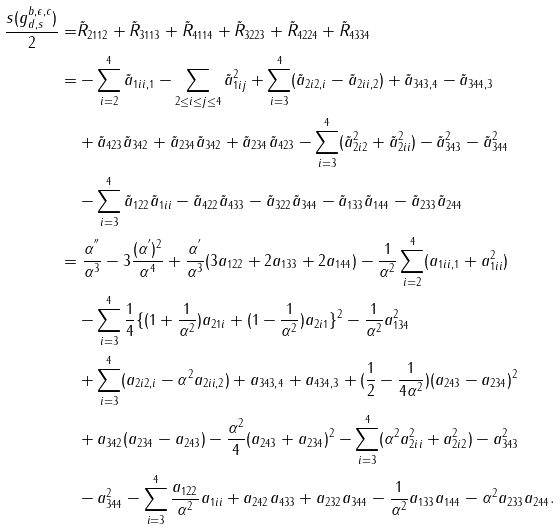<formula> <loc_0><loc_0><loc_500><loc_500>\frac { s ( g _ { d , s } ^ { b , \epsilon , c } ) } { 2 } = & \tilde { R } _ { 2 1 1 2 } + \tilde { R } _ { 3 1 1 3 } + \tilde { R } _ { 4 1 1 4 } + \tilde { R } _ { 3 2 2 3 } + \tilde { R } _ { 4 2 2 4 } + \tilde { R } _ { 4 3 3 4 } \\ = & - \sum _ { i = 2 } ^ { 4 } \tilde { a } _ { 1 i i , 1 } - \sum _ { 2 \leq i \leq j \leq 4 } \tilde { a } _ { 1 i j } ^ { 2 } + \sum _ { i = 3 } ^ { 4 } ( \tilde { a } _ { 2 i 2 , i } - \tilde { a } _ { 2 i i , 2 } ) + \tilde { a } _ { 3 4 3 , 4 } - \tilde { a } _ { 3 4 4 , 3 } \\ & + \tilde { a } _ { 4 2 3 } \tilde { a } _ { 3 4 2 } + \tilde { a } _ { 2 3 4 } \tilde { a } _ { 3 4 2 } + \tilde { a } _ { 2 3 4 } \tilde { a } _ { 4 2 3 } - \sum _ { i = 3 } ^ { 4 } ( \tilde { a } _ { 2 i 2 } ^ { 2 } + \tilde { a } _ { 2 i i } ^ { 2 } ) - \tilde { a } _ { 3 4 3 } ^ { 2 } - \tilde { a } _ { 3 4 4 } ^ { 2 } \\ & - \sum _ { i = 3 } ^ { 4 } \tilde { a } _ { 1 2 2 } \tilde { a } _ { 1 i i } - \tilde { a } _ { 4 2 2 } \tilde { a } _ { 4 3 3 } - \tilde { a } _ { 3 2 2 } \tilde { a } _ { 3 4 4 } - \tilde { a } _ { 1 3 3 } \tilde { a } _ { 1 4 4 } - \tilde { a } _ { 2 3 3 } \tilde { a } _ { 2 4 4 } \\ = & \ \frac { \alpha ^ { ^ { \prime \prime } } } { \alpha ^ { 3 } } - 3 \frac { ( \alpha ^ { ^ { \prime } } ) ^ { 2 } } { \alpha ^ { 4 } } + \frac { \alpha ^ { ^ { \prime } } } { \alpha ^ { 3 } } ( 3 a _ { 1 2 2 } + 2 a _ { 1 3 3 } + 2 a _ { 1 4 4 } ) - \frac { 1 } { \alpha ^ { 2 } } \sum _ { i = 2 } ^ { 4 } ( a _ { 1 i i , 1 } + a _ { 1 i i } ^ { 2 } ) \\ & - \sum _ { i = 3 } ^ { 4 } \frac { 1 } { 4 } \{ ( 1 + \frac { 1 } { \alpha ^ { 2 } } ) a _ { 2 1 i } + ( 1 - \frac { 1 } { \alpha ^ { 2 } } ) a _ { 2 i 1 } \} ^ { 2 } - \frac { 1 } { \alpha ^ { 2 } } a _ { 1 3 4 } ^ { 2 } \\ & + \sum _ { i = 3 } ^ { 4 } ( a _ { 2 i 2 , i } - \alpha ^ { 2 } a _ { 2 i i , 2 } ) + a _ { 3 4 3 , 4 } + a _ { 4 3 4 , 3 } + ( \frac { 1 } { 2 } - \frac { 1 } { 4 \alpha ^ { 2 } } ) ( a _ { 2 4 3 } - a _ { 2 3 4 } ) ^ { 2 } \\ & + a _ { 3 4 2 } ( a _ { 2 3 4 } - a _ { 2 4 3 } ) - \frac { \alpha ^ { 2 } } { 4 } ( a _ { 2 4 3 } + a _ { 2 3 4 } ) ^ { 2 } - \sum _ { i = 3 } ^ { 4 } ( \alpha ^ { 2 } a _ { 2 i i } ^ { 2 } + a _ { 2 i 2 } ^ { 2 } ) - a _ { 3 4 3 } ^ { 2 } \\ & - a _ { 3 4 4 } ^ { 2 } - \sum _ { i = 3 } ^ { 4 } \frac { a _ { 1 2 2 } } { \alpha ^ { 2 } } a _ { 1 i i } + a _ { 2 4 2 } a _ { 4 3 3 } + a _ { 2 3 2 } a _ { 3 4 4 } - \frac { 1 } { \alpha ^ { 2 } } a _ { 1 3 3 } a _ { 1 4 4 } - \alpha ^ { 2 } a _ { 2 3 3 } a _ { 2 4 4 } .</formula> 